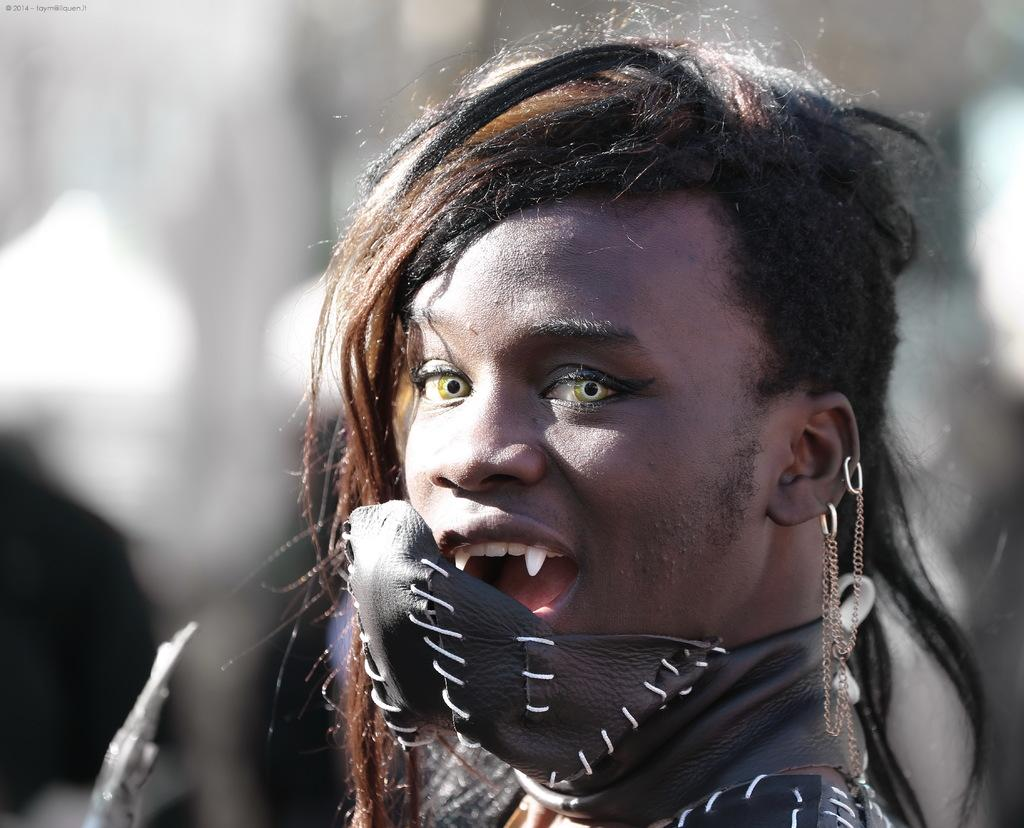What is the main subject of the image? There is a person in the image. Can you describe the background of the image? The background of the image is blurred. What type of rake is the grandmother using to serve the person in the image? There is no rake or grandmother present in the image. What is the occupation of the servant in the image? There is no servant present in the image. 